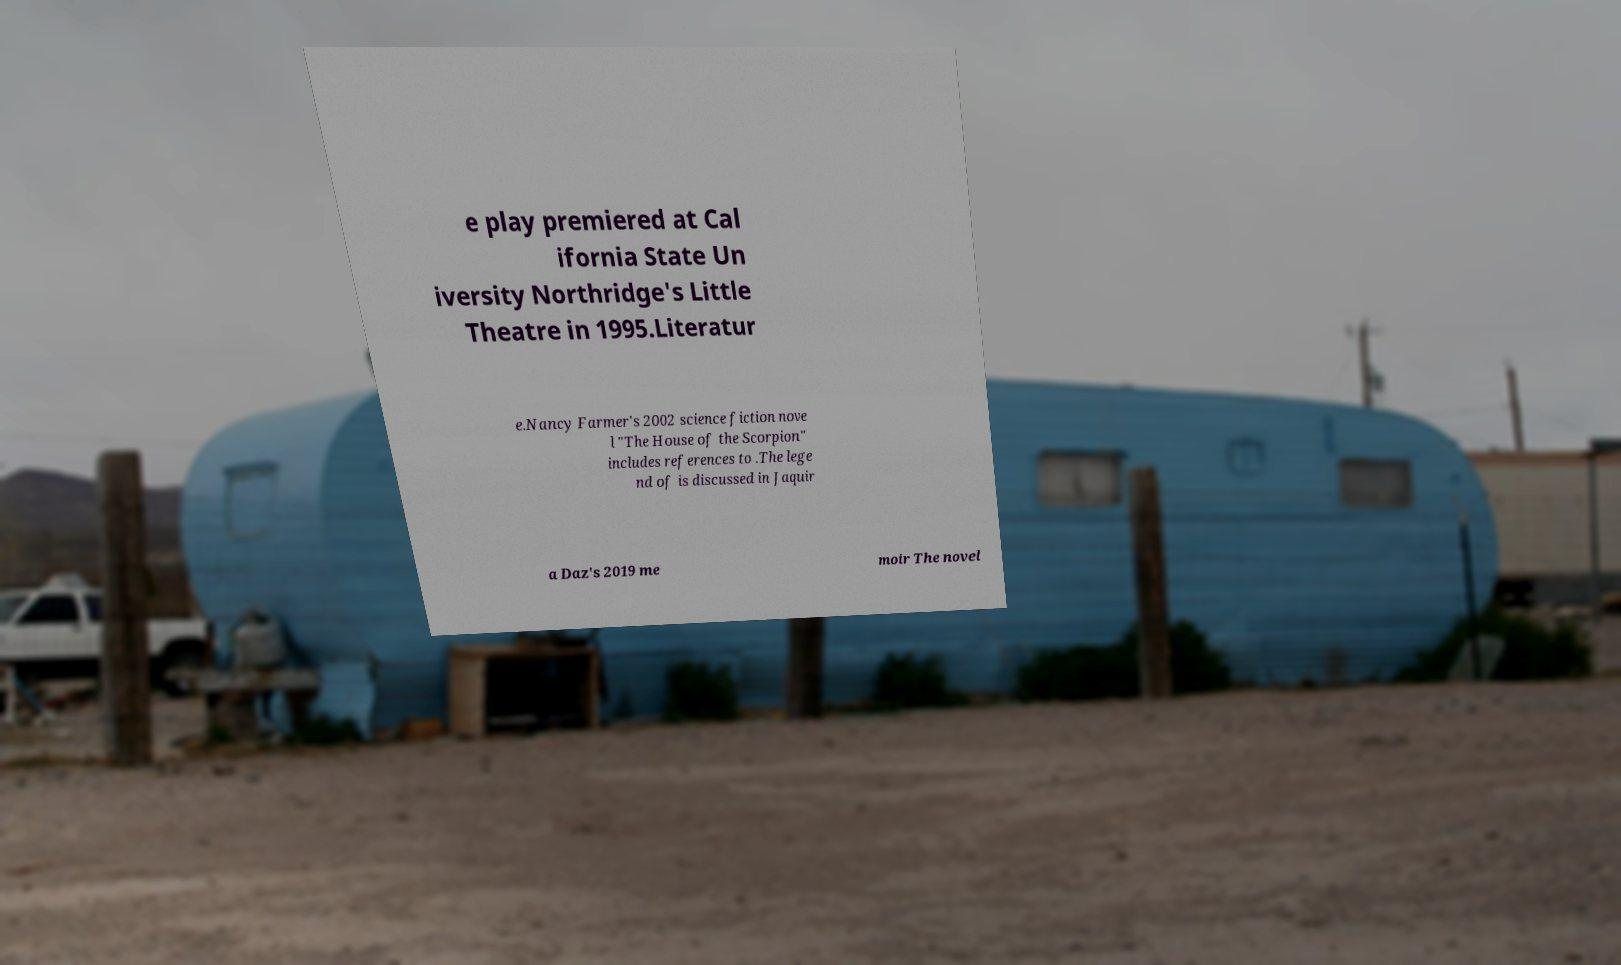I need the written content from this picture converted into text. Can you do that? e play premiered at Cal ifornia State Un iversity Northridge's Little Theatre in 1995.Literatur e.Nancy Farmer's 2002 science fiction nove l "The House of the Scorpion" includes references to .The lege nd of is discussed in Jaquir a Daz's 2019 me moir The novel 